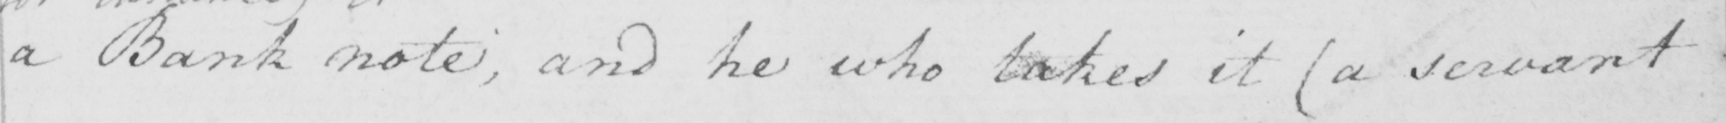Can you read and transcribe this handwriting? a Bank note and he who takes it  ( a servant 